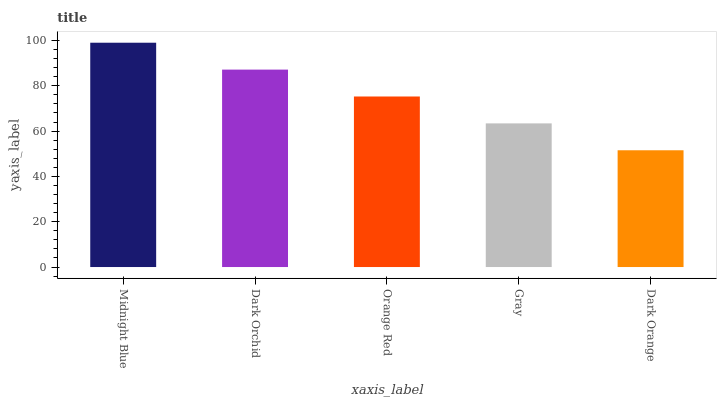Is Dark Orchid the minimum?
Answer yes or no. No. Is Dark Orchid the maximum?
Answer yes or no. No. Is Midnight Blue greater than Dark Orchid?
Answer yes or no. Yes. Is Dark Orchid less than Midnight Blue?
Answer yes or no. Yes. Is Dark Orchid greater than Midnight Blue?
Answer yes or no. No. Is Midnight Blue less than Dark Orchid?
Answer yes or no. No. Is Orange Red the high median?
Answer yes or no. Yes. Is Orange Red the low median?
Answer yes or no. Yes. Is Gray the high median?
Answer yes or no. No. Is Gray the low median?
Answer yes or no. No. 